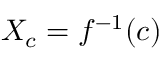<formula> <loc_0><loc_0><loc_500><loc_500>X _ { c } = f ^ { - 1 } ( c )</formula> 